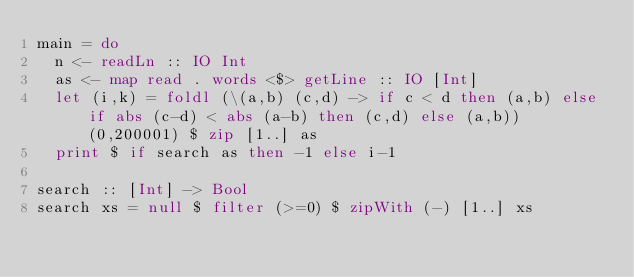Convert code to text. <code><loc_0><loc_0><loc_500><loc_500><_Haskell_>main = do
  n <- readLn :: IO Int
  as <- map read . words <$> getLine :: IO [Int]  
  let (i,k) = foldl (\(a,b) (c,d) -> if c < d then (a,b) else if abs (c-d) < abs (a-b) then (c,d) else (a,b)) (0,200001) $ zip [1..] as
  print $ if search as then -1 else i-1

search :: [Int] -> Bool
search xs = null $ filter (>=0) $ zipWith (-) [1..] xs</code> 